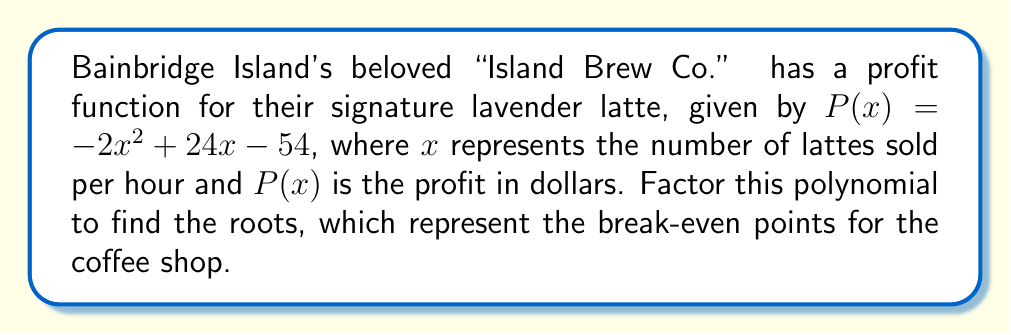Can you solve this math problem? To factor this quadratic polynomial, we'll use the following steps:

1) First, identify the coefficients:
   $a = -2$, $b = 24$, and $c = -54$

2) Calculate the discriminant:
   $b^2 - 4ac = 24^2 - 4(-2)(-54) = 576 - 432 = 144$

3) Since the discriminant is positive and a perfect square, this polynomial has two rational roots.

4) Use the quadratic formula to find the roots:
   $$x = \frac{-b \pm \sqrt{b^2 - 4ac}}{2a}$$
   $$x = \frac{-24 \pm \sqrt{144}}{-4} = \frac{-24 \pm 12}{-4}$$

5) Simplify:
   $$x = \frac{-24 + 12}{-4} = \frac{-12}{-4} = 3$$ or $$x = \frac{-24 - 12}{-4} = \frac{-36}{-4} = 9$$

6) The factored form of the polynomial is:
   $$P(x) = -2(x - 3)(x - 9)$$

This factorization shows that the break-even points occur when Island Brew Co. sells 3 or 9 lavender lattes per hour.
Answer: $P(x) = -2(x - 3)(x - 9)$ 